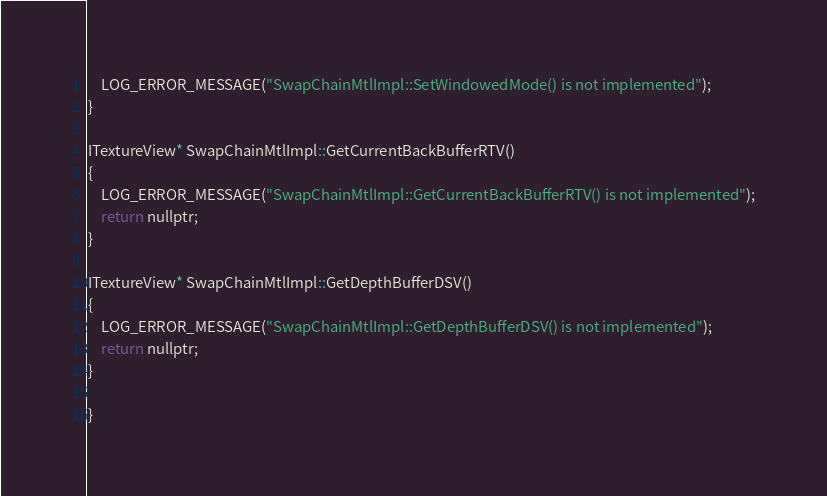Convert code to text. <code><loc_0><loc_0><loc_500><loc_500><_ObjectiveC_>    LOG_ERROR_MESSAGE("SwapChainMtlImpl::SetWindowedMode() is not implemented");
}

ITextureView* SwapChainMtlImpl::GetCurrentBackBufferRTV()
{
    LOG_ERROR_MESSAGE("SwapChainMtlImpl::GetCurrentBackBufferRTV() is not implemented");
    return nullptr;
}

ITextureView* SwapChainMtlImpl::GetDepthBufferDSV()
{
    LOG_ERROR_MESSAGE("SwapChainMtlImpl::GetDepthBufferDSV() is not implemented");
    return nullptr;
}

}
</code> 